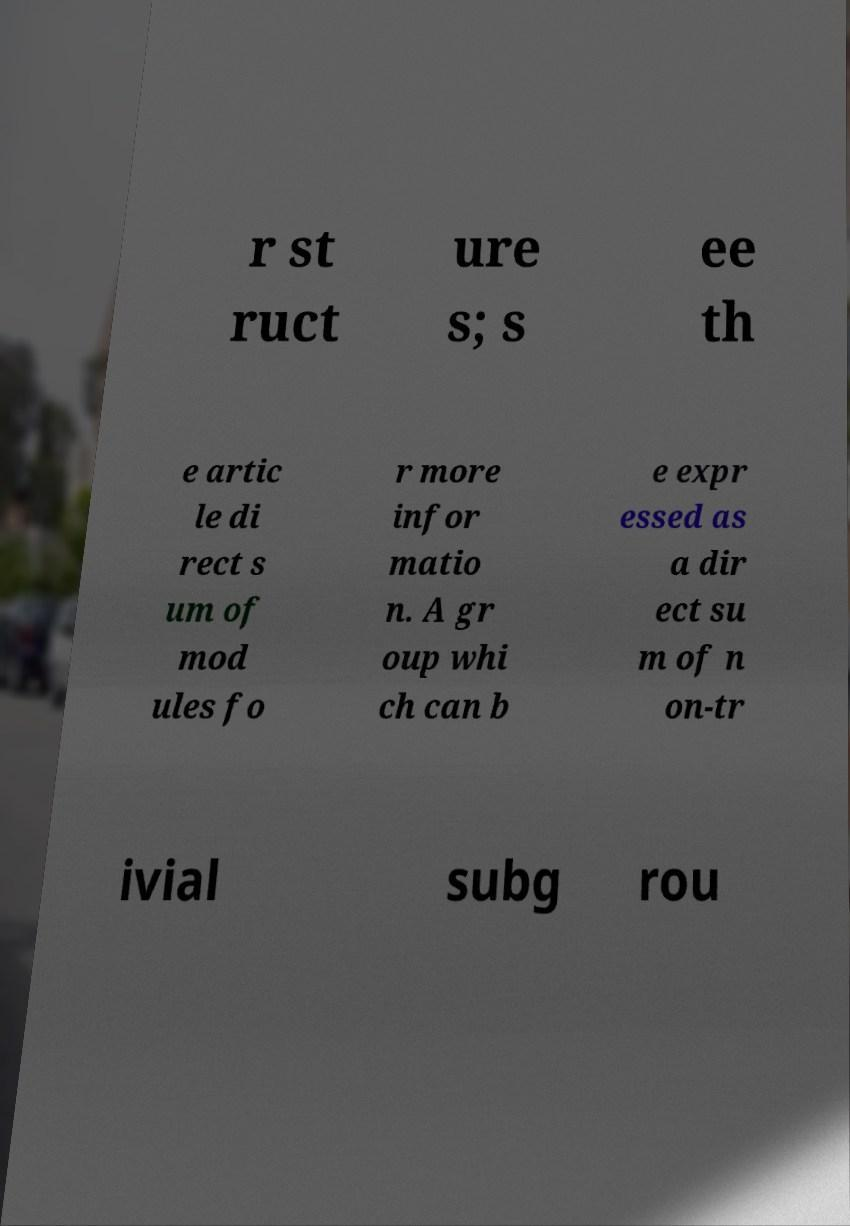Could you extract and type out the text from this image? r st ruct ure s; s ee th e artic le di rect s um of mod ules fo r more infor matio n. A gr oup whi ch can b e expr essed as a dir ect su m of n on-tr ivial subg rou 